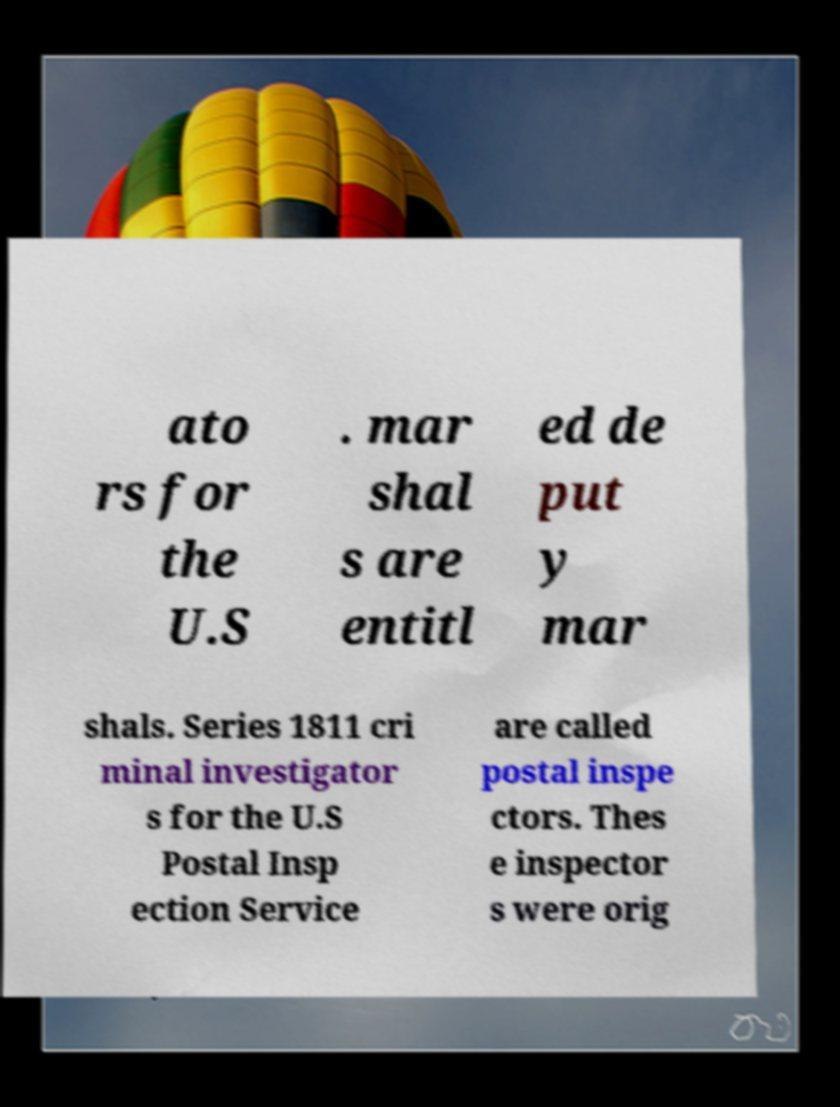For documentation purposes, I need the text within this image transcribed. Could you provide that? ato rs for the U.S . mar shal s are entitl ed de put y mar shals. Series 1811 cri minal investigator s for the U.S Postal Insp ection Service are called postal inspe ctors. Thes e inspector s were orig 